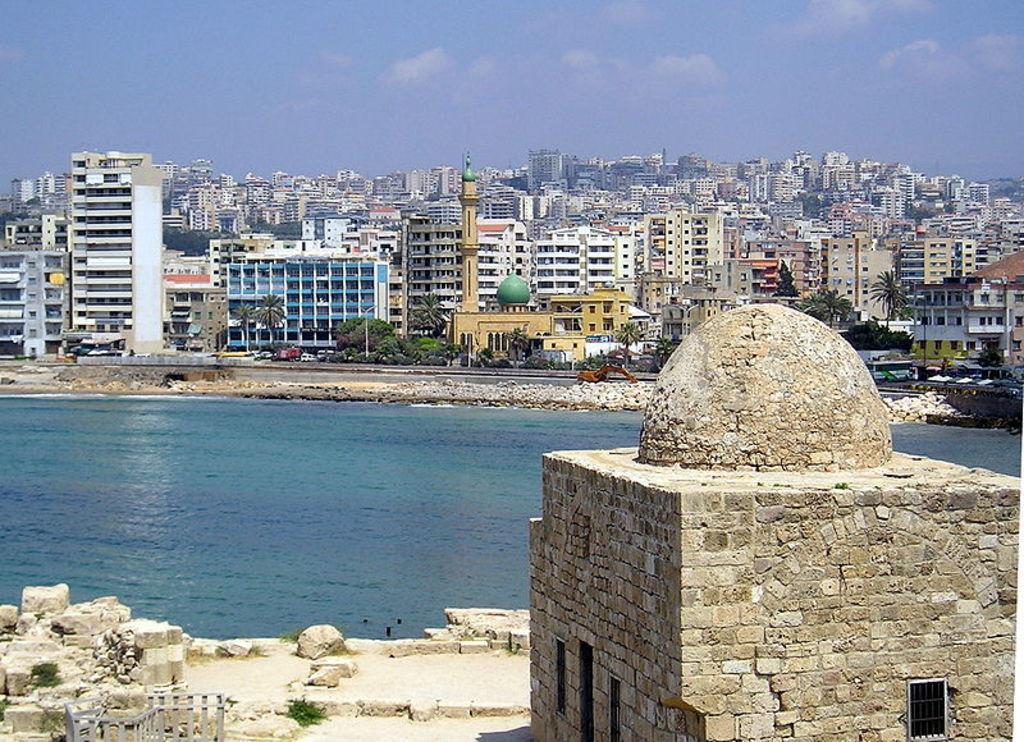Please provide a concise description of this image. In image in the center there is water. In the front there are stones on the ground and there is a house. In the background there are buildings and the sky is cloudy. 